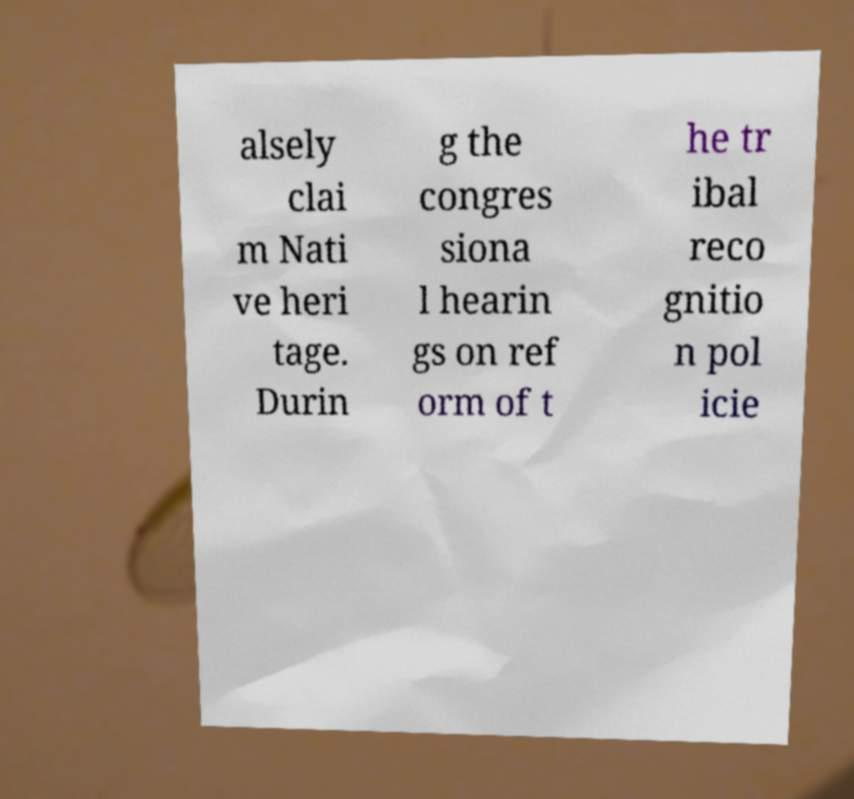Can you read and provide the text displayed in the image?This photo seems to have some interesting text. Can you extract and type it out for me? alsely clai m Nati ve heri tage. Durin g the congres siona l hearin gs on ref orm of t he tr ibal reco gnitio n pol icie 